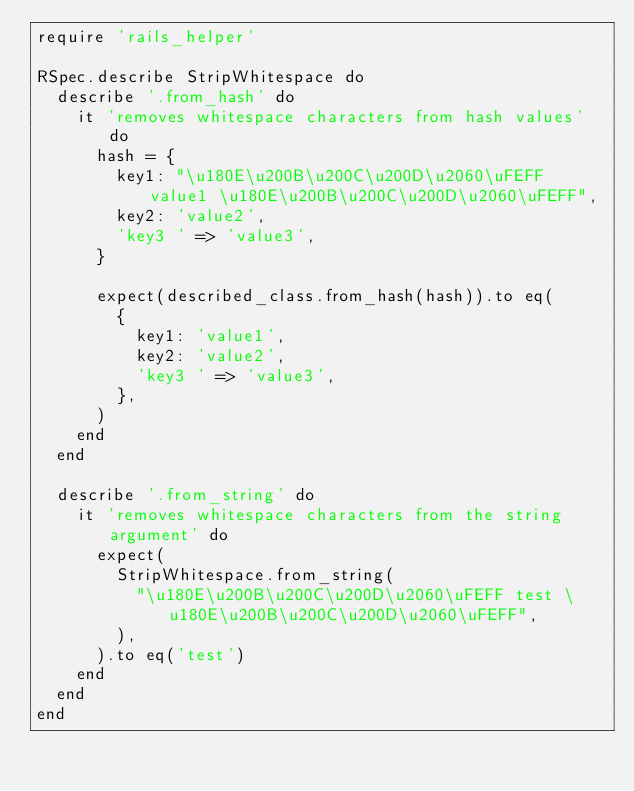Convert code to text. <code><loc_0><loc_0><loc_500><loc_500><_Ruby_>require 'rails_helper'

RSpec.describe StripWhitespace do
  describe '.from_hash' do
    it 'removes whitespace characters from hash values' do
      hash = {
        key1: "\u180E\u200B\u200C\u200D\u2060\uFEFF value1 \u180E\u200B\u200C\u200D\u2060\uFEFF",
        key2: 'value2',
        'key3 ' => 'value3',
      }

      expect(described_class.from_hash(hash)).to eq(
        {
          key1: 'value1',
          key2: 'value2',
          'key3 ' => 'value3',
        },
      )
    end
  end

  describe '.from_string' do
    it 'removes whitespace characters from the string argument' do
      expect(
        StripWhitespace.from_string(
          "\u180E\u200B\u200C\u200D\u2060\uFEFF test \u180E\u200B\u200C\u200D\u2060\uFEFF",
        ),
      ).to eq('test')
    end
  end
end
</code> 